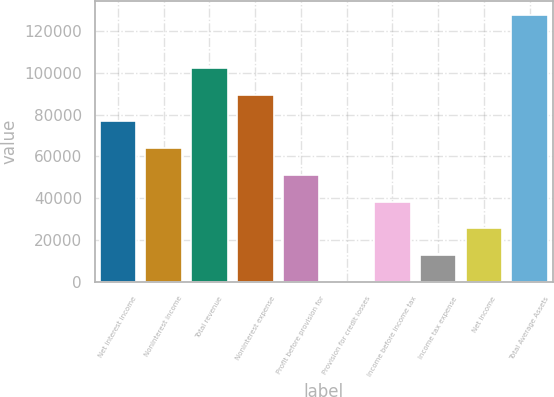Convert chart. <chart><loc_0><loc_0><loc_500><loc_500><bar_chart><fcel>Net interest income<fcel>Noninterest income<fcel>Total revenue<fcel>Noninterest expense<fcel>Profit before provision for<fcel>Provision for credit losses<fcel>Income before income tax<fcel>Income tax expense<fcel>Net income<fcel>Total Average Assets<nl><fcel>76702<fcel>63971.5<fcel>102163<fcel>89432.5<fcel>51241<fcel>319<fcel>38510.5<fcel>13049.5<fcel>25780<fcel>127624<nl></chart> 